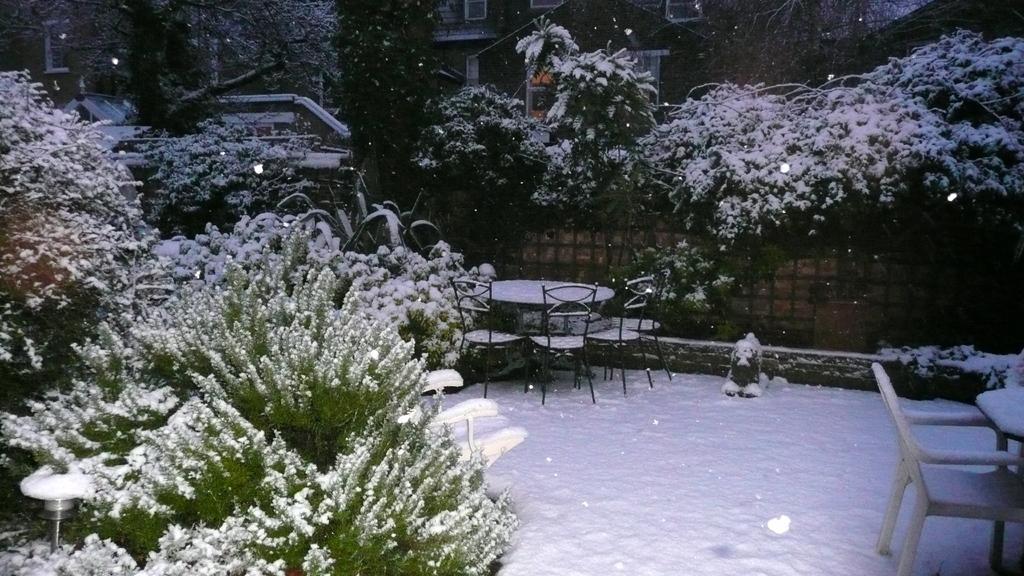What type of surface is visible in the image? There is a snow surface in the image. What objects are placed on the snow surface? There are empty chairs and tables on the snow surface. What structures can be seen around the snow surface? There are houses around the snow surface. What type of vegetation is present around the snow surface? There are trees around the snow surface. What type of dirt can be seen on the snow surface in the image? There is no dirt present on the snow surface in the image; it is a clean snow surface. Can you see any buildings being constructed in the image? There is no construction or building activity depicted in the image. 